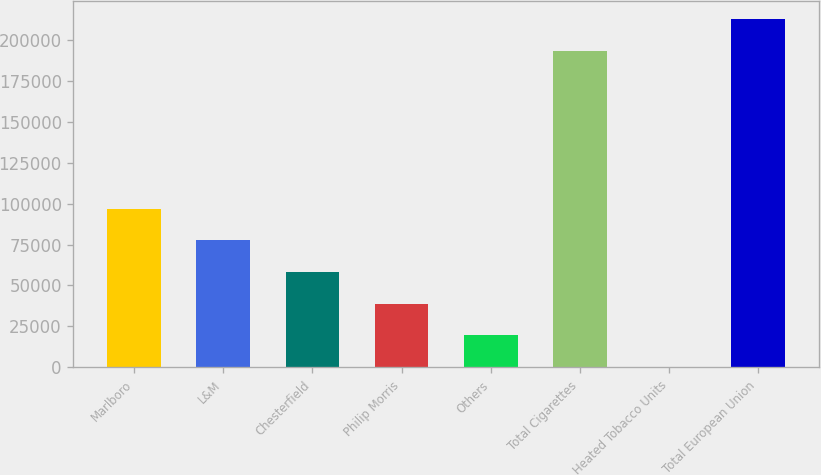Convert chart. <chart><loc_0><loc_0><loc_500><loc_500><bar_chart><fcel>Marlboro<fcel>L&M<fcel>Chesterfield<fcel>Philip Morris<fcel>Others<fcel>Total Cigarettes<fcel>Heated Tobacco Units<fcel>Total European Union<nl><fcel>97017<fcel>77658.4<fcel>58299.8<fcel>38941.2<fcel>19582.6<fcel>193586<fcel>224<fcel>212945<nl></chart> 